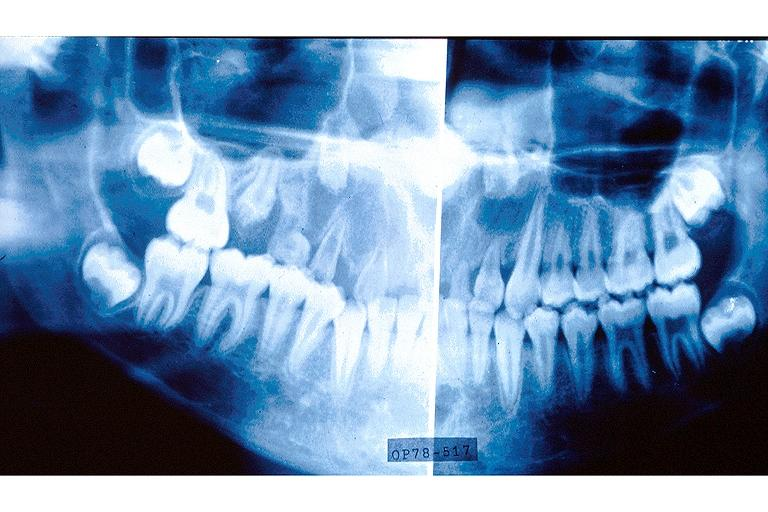where is this?
Answer the question using a single word or phrase. Oral 